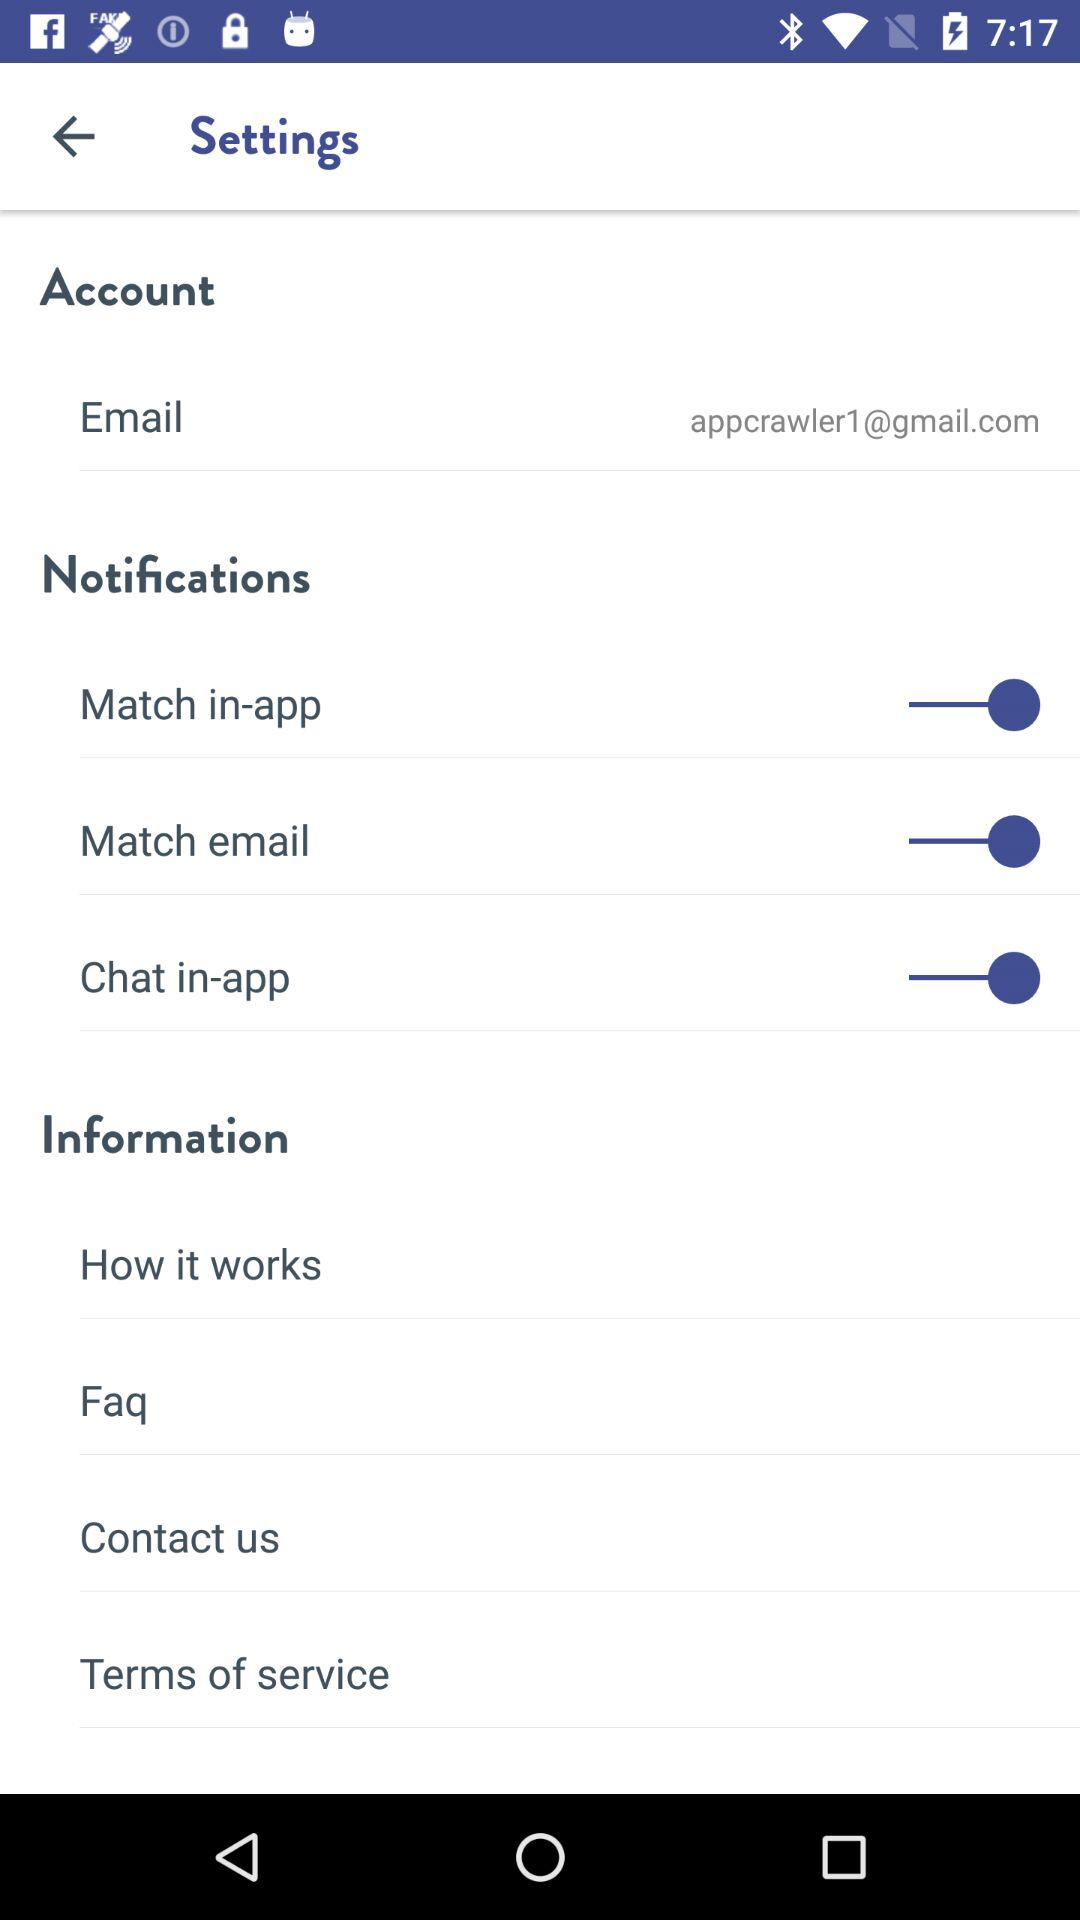What is the current status of the "Match in-app" notification setting? The status is "on". 